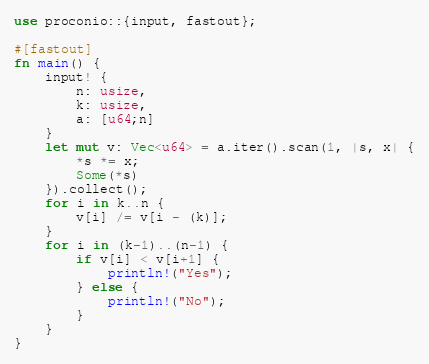<code> <loc_0><loc_0><loc_500><loc_500><_Rust_>use proconio::{input, fastout};

#[fastout]
fn main() {
    input! {
        n: usize,
        k: usize,
        a: [u64;n]
    }
    let mut v: Vec<u64> = a.iter().scan(1, |s, x| {
        *s *= x;
        Some(*s)
    }).collect();
    for i in k..n {
        v[i] /= v[i - (k)];
    }
    for i in (k-1)..(n-1) {
        if v[i] < v[i+1] {
            println!("Yes");
        } else {
            println!("No");
        }
    }
}
</code> 